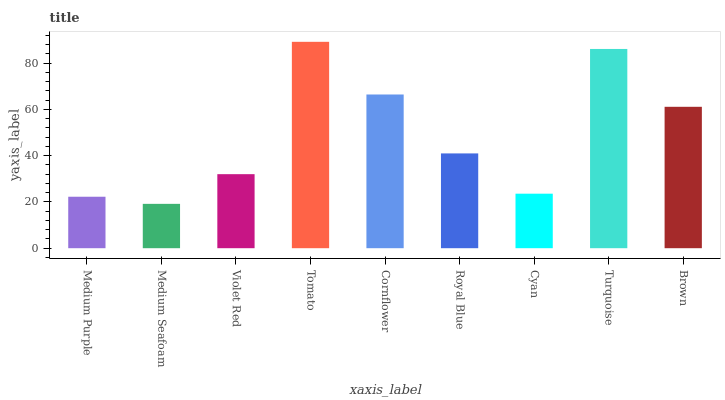Is Medium Seafoam the minimum?
Answer yes or no. Yes. Is Tomato the maximum?
Answer yes or no. Yes. Is Violet Red the minimum?
Answer yes or no. No. Is Violet Red the maximum?
Answer yes or no. No. Is Violet Red greater than Medium Seafoam?
Answer yes or no. Yes. Is Medium Seafoam less than Violet Red?
Answer yes or no. Yes. Is Medium Seafoam greater than Violet Red?
Answer yes or no. No. Is Violet Red less than Medium Seafoam?
Answer yes or no. No. Is Royal Blue the high median?
Answer yes or no. Yes. Is Royal Blue the low median?
Answer yes or no. Yes. Is Medium Purple the high median?
Answer yes or no. No. Is Cornflower the low median?
Answer yes or no. No. 